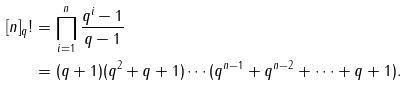<formula> <loc_0><loc_0><loc_500><loc_500>[ n ] _ { q } ! & = \prod _ { i = 1 } ^ { n } \frac { q ^ { i } - 1 } { q - 1 } \\ & = ( q + 1 ) ( q ^ { 2 } + q + 1 ) \cdots ( q ^ { n - 1 } + q ^ { n - 2 } + \cdots + q + 1 ) .</formula> 